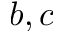Convert formula to latex. <formula><loc_0><loc_0><loc_500><loc_500>b , c</formula> 